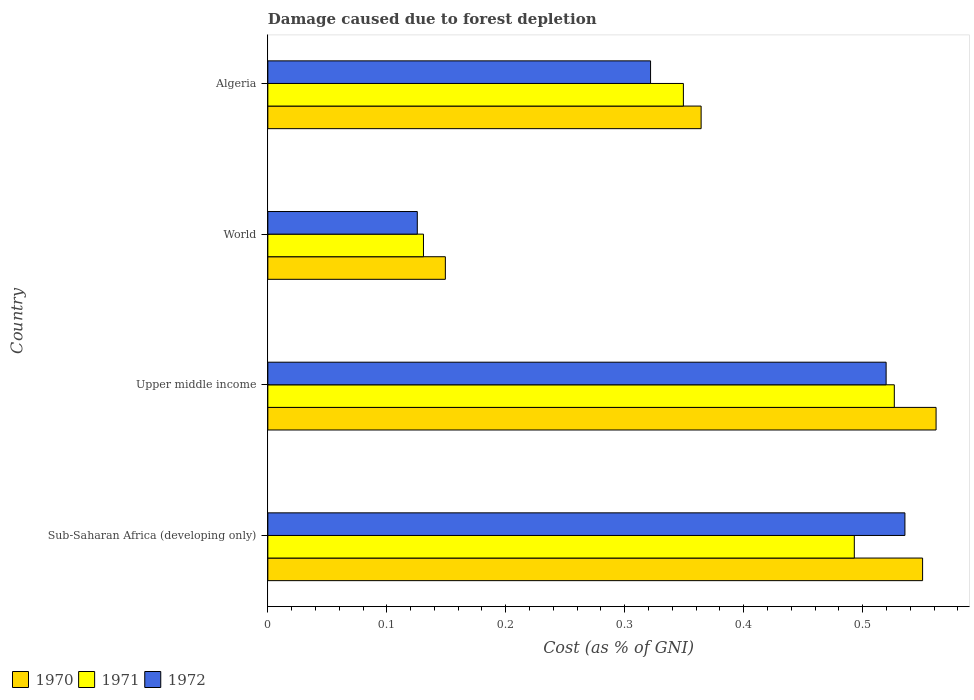How many different coloured bars are there?
Provide a succinct answer. 3. How many groups of bars are there?
Provide a short and direct response. 4. How many bars are there on the 2nd tick from the bottom?
Keep it short and to the point. 3. What is the label of the 3rd group of bars from the top?
Your answer should be very brief. Upper middle income. What is the cost of damage caused due to forest depletion in 1970 in Upper middle income?
Provide a succinct answer. 0.56. Across all countries, what is the maximum cost of damage caused due to forest depletion in 1970?
Offer a very short reply. 0.56. Across all countries, what is the minimum cost of damage caused due to forest depletion in 1972?
Provide a short and direct response. 0.13. In which country was the cost of damage caused due to forest depletion in 1971 maximum?
Offer a very short reply. Upper middle income. In which country was the cost of damage caused due to forest depletion in 1971 minimum?
Offer a very short reply. World. What is the total cost of damage caused due to forest depletion in 1972 in the graph?
Your answer should be compact. 1.5. What is the difference between the cost of damage caused due to forest depletion in 1972 in Sub-Saharan Africa (developing only) and that in World?
Your answer should be compact. 0.41. What is the difference between the cost of damage caused due to forest depletion in 1972 in Algeria and the cost of damage caused due to forest depletion in 1970 in World?
Your response must be concise. 0.17. What is the average cost of damage caused due to forest depletion in 1972 per country?
Provide a succinct answer. 0.38. What is the difference between the cost of damage caused due to forest depletion in 1971 and cost of damage caused due to forest depletion in 1972 in Sub-Saharan Africa (developing only)?
Keep it short and to the point. -0.04. What is the ratio of the cost of damage caused due to forest depletion in 1972 in Sub-Saharan Africa (developing only) to that in Upper middle income?
Offer a very short reply. 1.03. Is the difference between the cost of damage caused due to forest depletion in 1971 in Algeria and Upper middle income greater than the difference between the cost of damage caused due to forest depletion in 1972 in Algeria and Upper middle income?
Make the answer very short. Yes. What is the difference between the highest and the second highest cost of damage caused due to forest depletion in 1971?
Provide a short and direct response. 0.03. What is the difference between the highest and the lowest cost of damage caused due to forest depletion in 1972?
Provide a succinct answer. 0.41. What does the 2nd bar from the bottom in World represents?
Your answer should be compact. 1971. Is it the case that in every country, the sum of the cost of damage caused due to forest depletion in 1970 and cost of damage caused due to forest depletion in 1971 is greater than the cost of damage caused due to forest depletion in 1972?
Your response must be concise. Yes. How many bars are there?
Keep it short and to the point. 12. How many countries are there in the graph?
Offer a terse response. 4. What is the difference between two consecutive major ticks on the X-axis?
Make the answer very short. 0.1. Are the values on the major ticks of X-axis written in scientific E-notation?
Offer a terse response. No. Does the graph contain any zero values?
Your response must be concise. No. How are the legend labels stacked?
Offer a terse response. Horizontal. What is the title of the graph?
Make the answer very short. Damage caused due to forest depletion. Does "1985" appear as one of the legend labels in the graph?
Your response must be concise. No. What is the label or title of the X-axis?
Keep it short and to the point. Cost (as % of GNI). What is the Cost (as % of GNI) in 1970 in Sub-Saharan Africa (developing only)?
Ensure brevity in your answer.  0.55. What is the Cost (as % of GNI) of 1971 in Sub-Saharan Africa (developing only)?
Provide a short and direct response. 0.49. What is the Cost (as % of GNI) of 1972 in Sub-Saharan Africa (developing only)?
Your response must be concise. 0.54. What is the Cost (as % of GNI) of 1970 in Upper middle income?
Offer a very short reply. 0.56. What is the Cost (as % of GNI) of 1971 in Upper middle income?
Provide a short and direct response. 0.53. What is the Cost (as % of GNI) in 1972 in Upper middle income?
Give a very brief answer. 0.52. What is the Cost (as % of GNI) in 1970 in World?
Your answer should be compact. 0.15. What is the Cost (as % of GNI) in 1971 in World?
Your answer should be very brief. 0.13. What is the Cost (as % of GNI) in 1972 in World?
Make the answer very short. 0.13. What is the Cost (as % of GNI) of 1970 in Algeria?
Ensure brevity in your answer.  0.36. What is the Cost (as % of GNI) of 1971 in Algeria?
Give a very brief answer. 0.35. What is the Cost (as % of GNI) of 1972 in Algeria?
Your response must be concise. 0.32. Across all countries, what is the maximum Cost (as % of GNI) in 1970?
Your answer should be very brief. 0.56. Across all countries, what is the maximum Cost (as % of GNI) in 1971?
Give a very brief answer. 0.53. Across all countries, what is the maximum Cost (as % of GNI) in 1972?
Ensure brevity in your answer.  0.54. Across all countries, what is the minimum Cost (as % of GNI) in 1970?
Keep it short and to the point. 0.15. Across all countries, what is the minimum Cost (as % of GNI) of 1971?
Your answer should be very brief. 0.13. Across all countries, what is the minimum Cost (as % of GNI) in 1972?
Ensure brevity in your answer.  0.13. What is the total Cost (as % of GNI) in 1970 in the graph?
Offer a terse response. 1.63. What is the total Cost (as % of GNI) of 1971 in the graph?
Give a very brief answer. 1.5. What is the total Cost (as % of GNI) of 1972 in the graph?
Your answer should be very brief. 1.5. What is the difference between the Cost (as % of GNI) of 1970 in Sub-Saharan Africa (developing only) and that in Upper middle income?
Your answer should be compact. -0.01. What is the difference between the Cost (as % of GNI) of 1971 in Sub-Saharan Africa (developing only) and that in Upper middle income?
Your answer should be compact. -0.03. What is the difference between the Cost (as % of GNI) of 1972 in Sub-Saharan Africa (developing only) and that in Upper middle income?
Your answer should be very brief. 0.02. What is the difference between the Cost (as % of GNI) in 1970 in Sub-Saharan Africa (developing only) and that in World?
Make the answer very short. 0.4. What is the difference between the Cost (as % of GNI) in 1971 in Sub-Saharan Africa (developing only) and that in World?
Provide a succinct answer. 0.36. What is the difference between the Cost (as % of GNI) of 1972 in Sub-Saharan Africa (developing only) and that in World?
Make the answer very short. 0.41. What is the difference between the Cost (as % of GNI) in 1970 in Sub-Saharan Africa (developing only) and that in Algeria?
Offer a very short reply. 0.19. What is the difference between the Cost (as % of GNI) of 1971 in Sub-Saharan Africa (developing only) and that in Algeria?
Offer a terse response. 0.14. What is the difference between the Cost (as % of GNI) of 1972 in Sub-Saharan Africa (developing only) and that in Algeria?
Ensure brevity in your answer.  0.21. What is the difference between the Cost (as % of GNI) of 1970 in Upper middle income and that in World?
Your answer should be compact. 0.41. What is the difference between the Cost (as % of GNI) of 1971 in Upper middle income and that in World?
Offer a terse response. 0.4. What is the difference between the Cost (as % of GNI) in 1972 in Upper middle income and that in World?
Your answer should be compact. 0.39. What is the difference between the Cost (as % of GNI) of 1970 in Upper middle income and that in Algeria?
Make the answer very short. 0.2. What is the difference between the Cost (as % of GNI) in 1971 in Upper middle income and that in Algeria?
Your answer should be compact. 0.18. What is the difference between the Cost (as % of GNI) in 1972 in Upper middle income and that in Algeria?
Provide a short and direct response. 0.2. What is the difference between the Cost (as % of GNI) in 1970 in World and that in Algeria?
Ensure brevity in your answer.  -0.21. What is the difference between the Cost (as % of GNI) of 1971 in World and that in Algeria?
Offer a very short reply. -0.22. What is the difference between the Cost (as % of GNI) of 1972 in World and that in Algeria?
Your response must be concise. -0.2. What is the difference between the Cost (as % of GNI) of 1970 in Sub-Saharan Africa (developing only) and the Cost (as % of GNI) of 1971 in Upper middle income?
Give a very brief answer. 0.02. What is the difference between the Cost (as % of GNI) in 1970 in Sub-Saharan Africa (developing only) and the Cost (as % of GNI) in 1972 in Upper middle income?
Your answer should be compact. 0.03. What is the difference between the Cost (as % of GNI) in 1971 in Sub-Saharan Africa (developing only) and the Cost (as % of GNI) in 1972 in Upper middle income?
Provide a succinct answer. -0.03. What is the difference between the Cost (as % of GNI) in 1970 in Sub-Saharan Africa (developing only) and the Cost (as % of GNI) in 1971 in World?
Make the answer very short. 0.42. What is the difference between the Cost (as % of GNI) in 1970 in Sub-Saharan Africa (developing only) and the Cost (as % of GNI) in 1972 in World?
Keep it short and to the point. 0.42. What is the difference between the Cost (as % of GNI) in 1971 in Sub-Saharan Africa (developing only) and the Cost (as % of GNI) in 1972 in World?
Make the answer very short. 0.37. What is the difference between the Cost (as % of GNI) in 1970 in Sub-Saharan Africa (developing only) and the Cost (as % of GNI) in 1971 in Algeria?
Provide a short and direct response. 0.2. What is the difference between the Cost (as % of GNI) of 1970 in Sub-Saharan Africa (developing only) and the Cost (as % of GNI) of 1972 in Algeria?
Keep it short and to the point. 0.23. What is the difference between the Cost (as % of GNI) of 1971 in Sub-Saharan Africa (developing only) and the Cost (as % of GNI) of 1972 in Algeria?
Ensure brevity in your answer.  0.17. What is the difference between the Cost (as % of GNI) of 1970 in Upper middle income and the Cost (as % of GNI) of 1971 in World?
Provide a short and direct response. 0.43. What is the difference between the Cost (as % of GNI) of 1970 in Upper middle income and the Cost (as % of GNI) of 1972 in World?
Provide a succinct answer. 0.44. What is the difference between the Cost (as % of GNI) in 1971 in Upper middle income and the Cost (as % of GNI) in 1972 in World?
Ensure brevity in your answer.  0.4. What is the difference between the Cost (as % of GNI) of 1970 in Upper middle income and the Cost (as % of GNI) of 1971 in Algeria?
Provide a short and direct response. 0.21. What is the difference between the Cost (as % of GNI) in 1970 in Upper middle income and the Cost (as % of GNI) in 1972 in Algeria?
Make the answer very short. 0.24. What is the difference between the Cost (as % of GNI) in 1971 in Upper middle income and the Cost (as % of GNI) in 1972 in Algeria?
Provide a short and direct response. 0.2. What is the difference between the Cost (as % of GNI) in 1970 in World and the Cost (as % of GNI) in 1971 in Algeria?
Provide a succinct answer. -0.2. What is the difference between the Cost (as % of GNI) in 1970 in World and the Cost (as % of GNI) in 1972 in Algeria?
Your response must be concise. -0.17. What is the difference between the Cost (as % of GNI) of 1971 in World and the Cost (as % of GNI) of 1972 in Algeria?
Offer a very short reply. -0.19. What is the average Cost (as % of GNI) of 1970 per country?
Give a very brief answer. 0.41. What is the average Cost (as % of GNI) in 1971 per country?
Ensure brevity in your answer.  0.37. What is the average Cost (as % of GNI) of 1972 per country?
Provide a short and direct response. 0.38. What is the difference between the Cost (as % of GNI) of 1970 and Cost (as % of GNI) of 1971 in Sub-Saharan Africa (developing only)?
Give a very brief answer. 0.06. What is the difference between the Cost (as % of GNI) of 1970 and Cost (as % of GNI) of 1972 in Sub-Saharan Africa (developing only)?
Make the answer very short. 0.01. What is the difference between the Cost (as % of GNI) in 1971 and Cost (as % of GNI) in 1972 in Sub-Saharan Africa (developing only)?
Provide a succinct answer. -0.04. What is the difference between the Cost (as % of GNI) of 1970 and Cost (as % of GNI) of 1971 in Upper middle income?
Your response must be concise. 0.04. What is the difference between the Cost (as % of GNI) in 1970 and Cost (as % of GNI) in 1972 in Upper middle income?
Your answer should be compact. 0.04. What is the difference between the Cost (as % of GNI) in 1971 and Cost (as % of GNI) in 1972 in Upper middle income?
Give a very brief answer. 0.01. What is the difference between the Cost (as % of GNI) in 1970 and Cost (as % of GNI) in 1971 in World?
Your answer should be very brief. 0.02. What is the difference between the Cost (as % of GNI) in 1970 and Cost (as % of GNI) in 1972 in World?
Your response must be concise. 0.02. What is the difference between the Cost (as % of GNI) of 1971 and Cost (as % of GNI) of 1972 in World?
Offer a terse response. 0.01. What is the difference between the Cost (as % of GNI) in 1970 and Cost (as % of GNI) in 1971 in Algeria?
Ensure brevity in your answer.  0.01. What is the difference between the Cost (as % of GNI) in 1970 and Cost (as % of GNI) in 1972 in Algeria?
Your answer should be compact. 0.04. What is the difference between the Cost (as % of GNI) in 1971 and Cost (as % of GNI) in 1972 in Algeria?
Ensure brevity in your answer.  0.03. What is the ratio of the Cost (as % of GNI) of 1970 in Sub-Saharan Africa (developing only) to that in Upper middle income?
Your response must be concise. 0.98. What is the ratio of the Cost (as % of GNI) in 1971 in Sub-Saharan Africa (developing only) to that in Upper middle income?
Provide a succinct answer. 0.94. What is the ratio of the Cost (as % of GNI) in 1972 in Sub-Saharan Africa (developing only) to that in Upper middle income?
Keep it short and to the point. 1.03. What is the ratio of the Cost (as % of GNI) of 1970 in Sub-Saharan Africa (developing only) to that in World?
Offer a very short reply. 3.69. What is the ratio of the Cost (as % of GNI) of 1971 in Sub-Saharan Africa (developing only) to that in World?
Your answer should be compact. 3.77. What is the ratio of the Cost (as % of GNI) of 1972 in Sub-Saharan Africa (developing only) to that in World?
Offer a terse response. 4.26. What is the ratio of the Cost (as % of GNI) of 1970 in Sub-Saharan Africa (developing only) to that in Algeria?
Make the answer very short. 1.51. What is the ratio of the Cost (as % of GNI) in 1971 in Sub-Saharan Africa (developing only) to that in Algeria?
Offer a very short reply. 1.41. What is the ratio of the Cost (as % of GNI) in 1972 in Sub-Saharan Africa (developing only) to that in Algeria?
Provide a short and direct response. 1.66. What is the ratio of the Cost (as % of GNI) of 1970 in Upper middle income to that in World?
Your response must be concise. 3.76. What is the ratio of the Cost (as % of GNI) in 1971 in Upper middle income to that in World?
Your response must be concise. 4.03. What is the ratio of the Cost (as % of GNI) of 1972 in Upper middle income to that in World?
Offer a terse response. 4.14. What is the ratio of the Cost (as % of GNI) of 1970 in Upper middle income to that in Algeria?
Make the answer very short. 1.54. What is the ratio of the Cost (as % of GNI) of 1971 in Upper middle income to that in Algeria?
Your answer should be compact. 1.51. What is the ratio of the Cost (as % of GNI) of 1972 in Upper middle income to that in Algeria?
Provide a succinct answer. 1.62. What is the ratio of the Cost (as % of GNI) in 1970 in World to that in Algeria?
Offer a very short reply. 0.41. What is the ratio of the Cost (as % of GNI) in 1971 in World to that in Algeria?
Your response must be concise. 0.37. What is the ratio of the Cost (as % of GNI) in 1972 in World to that in Algeria?
Offer a very short reply. 0.39. What is the difference between the highest and the second highest Cost (as % of GNI) in 1970?
Your answer should be very brief. 0.01. What is the difference between the highest and the second highest Cost (as % of GNI) of 1971?
Give a very brief answer. 0.03. What is the difference between the highest and the second highest Cost (as % of GNI) in 1972?
Your response must be concise. 0.02. What is the difference between the highest and the lowest Cost (as % of GNI) in 1970?
Provide a short and direct response. 0.41. What is the difference between the highest and the lowest Cost (as % of GNI) of 1971?
Make the answer very short. 0.4. What is the difference between the highest and the lowest Cost (as % of GNI) in 1972?
Provide a short and direct response. 0.41. 